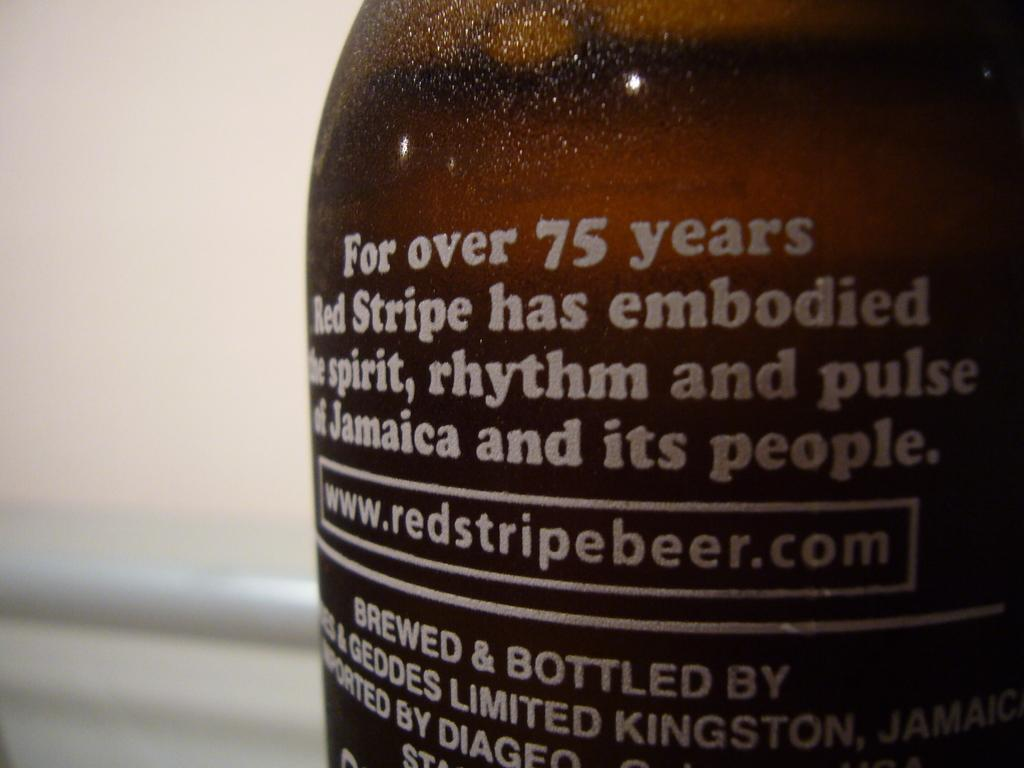<image>
Relay a brief, clear account of the picture shown. A bit of text on the back of a Red Stripe beer and url for the company. 